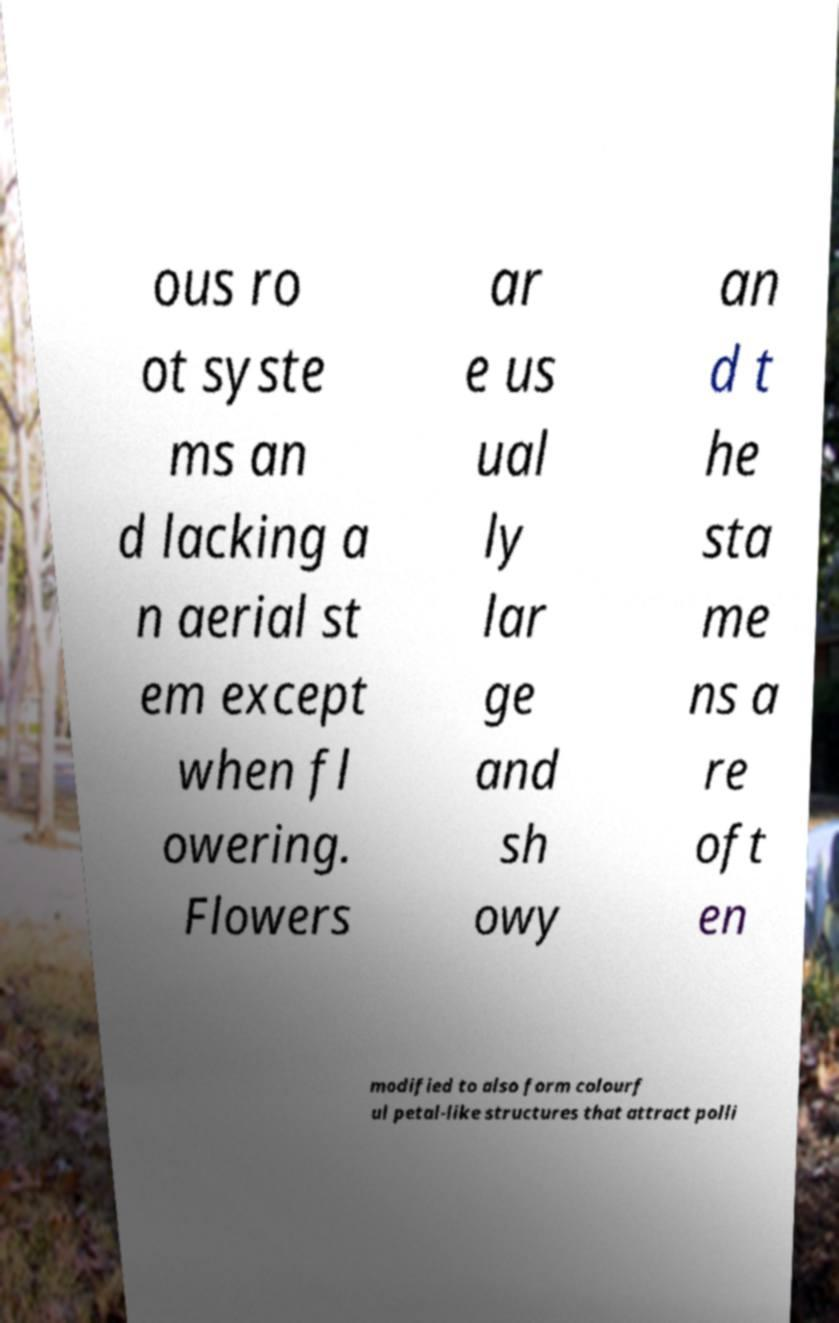Could you assist in decoding the text presented in this image and type it out clearly? ous ro ot syste ms an d lacking a n aerial st em except when fl owering. Flowers ar e us ual ly lar ge and sh owy an d t he sta me ns a re oft en modified to also form colourf ul petal-like structures that attract polli 